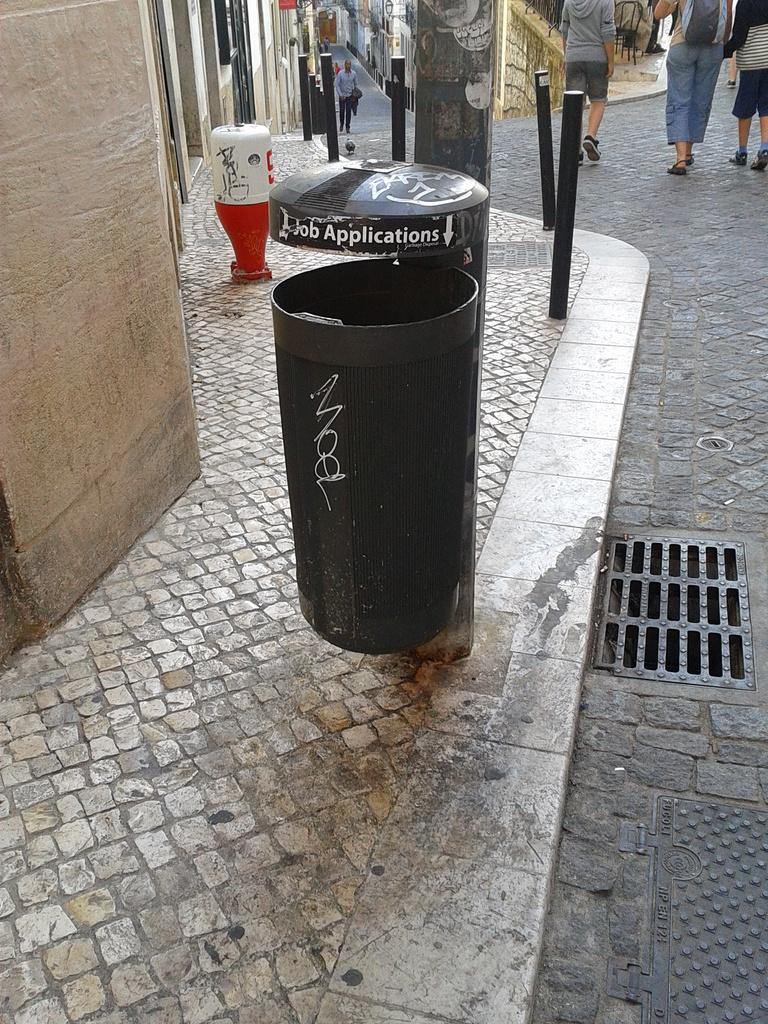What should we throw in the garbage?
Offer a very short reply. Job applications. 